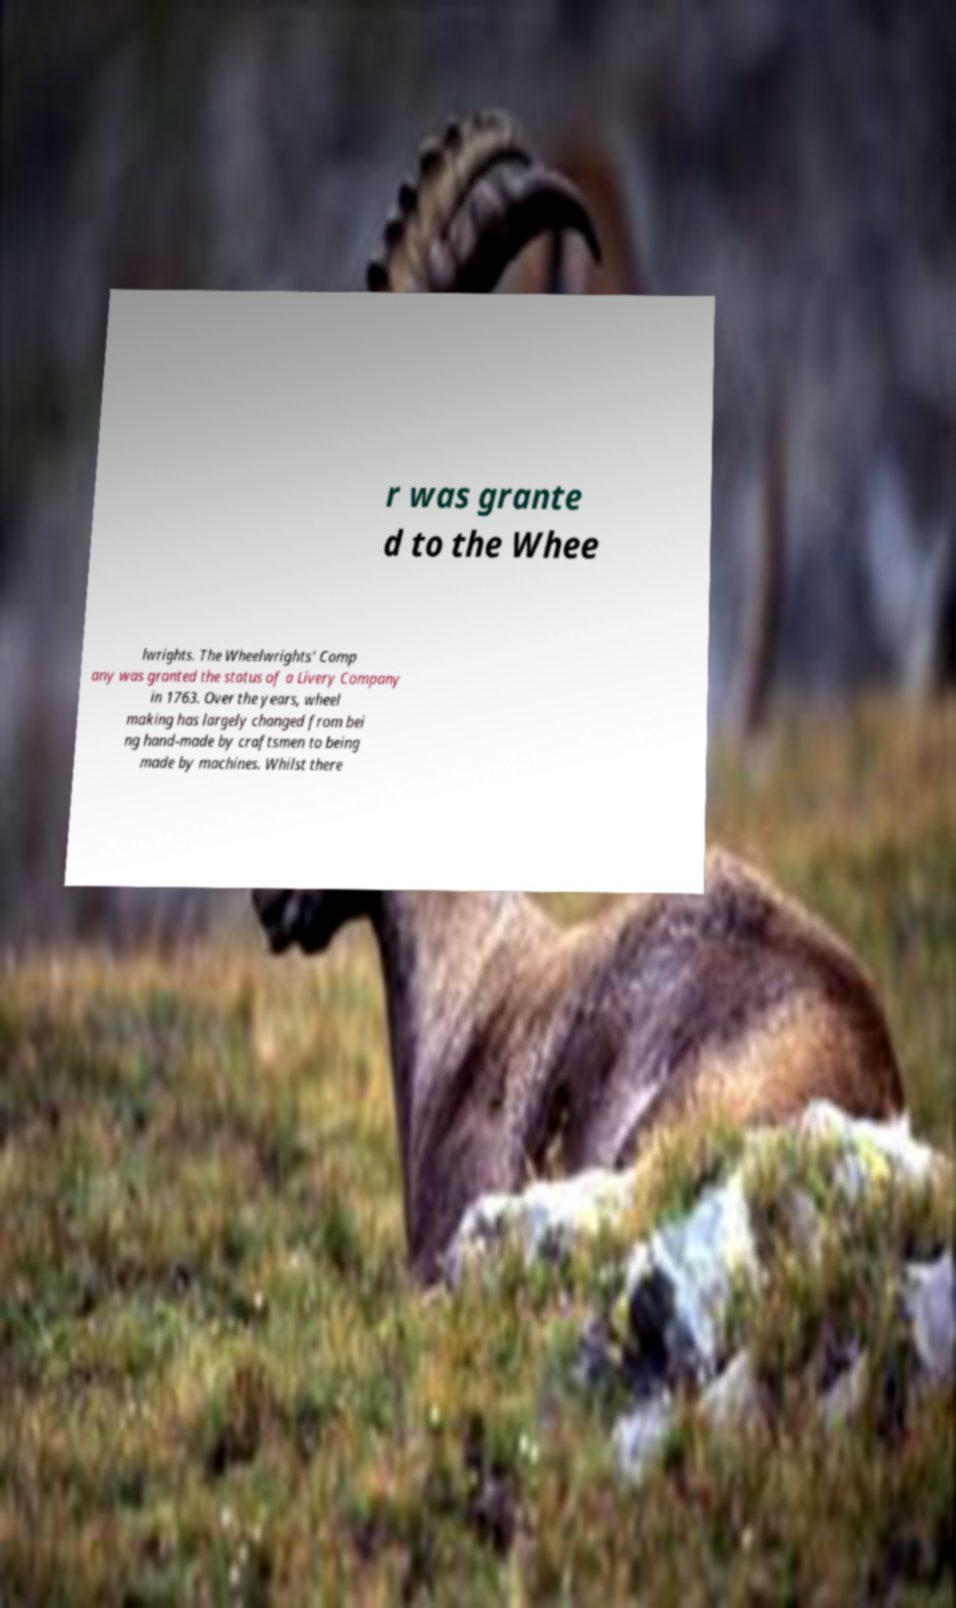I need the written content from this picture converted into text. Can you do that? r was grante d to the Whee lwrights. The Wheelwrights' Comp any was granted the status of a Livery Company in 1763. Over the years, wheel making has largely changed from bei ng hand-made by craftsmen to being made by machines. Whilst there 